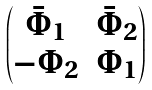<formula> <loc_0><loc_0><loc_500><loc_500>\begin{pmatrix} \bar { \Phi } _ { 1 } & \bar { \Phi } _ { 2 } \\ - \Phi _ { 2 } & \Phi _ { 1 } \end{pmatrix}</formula> 